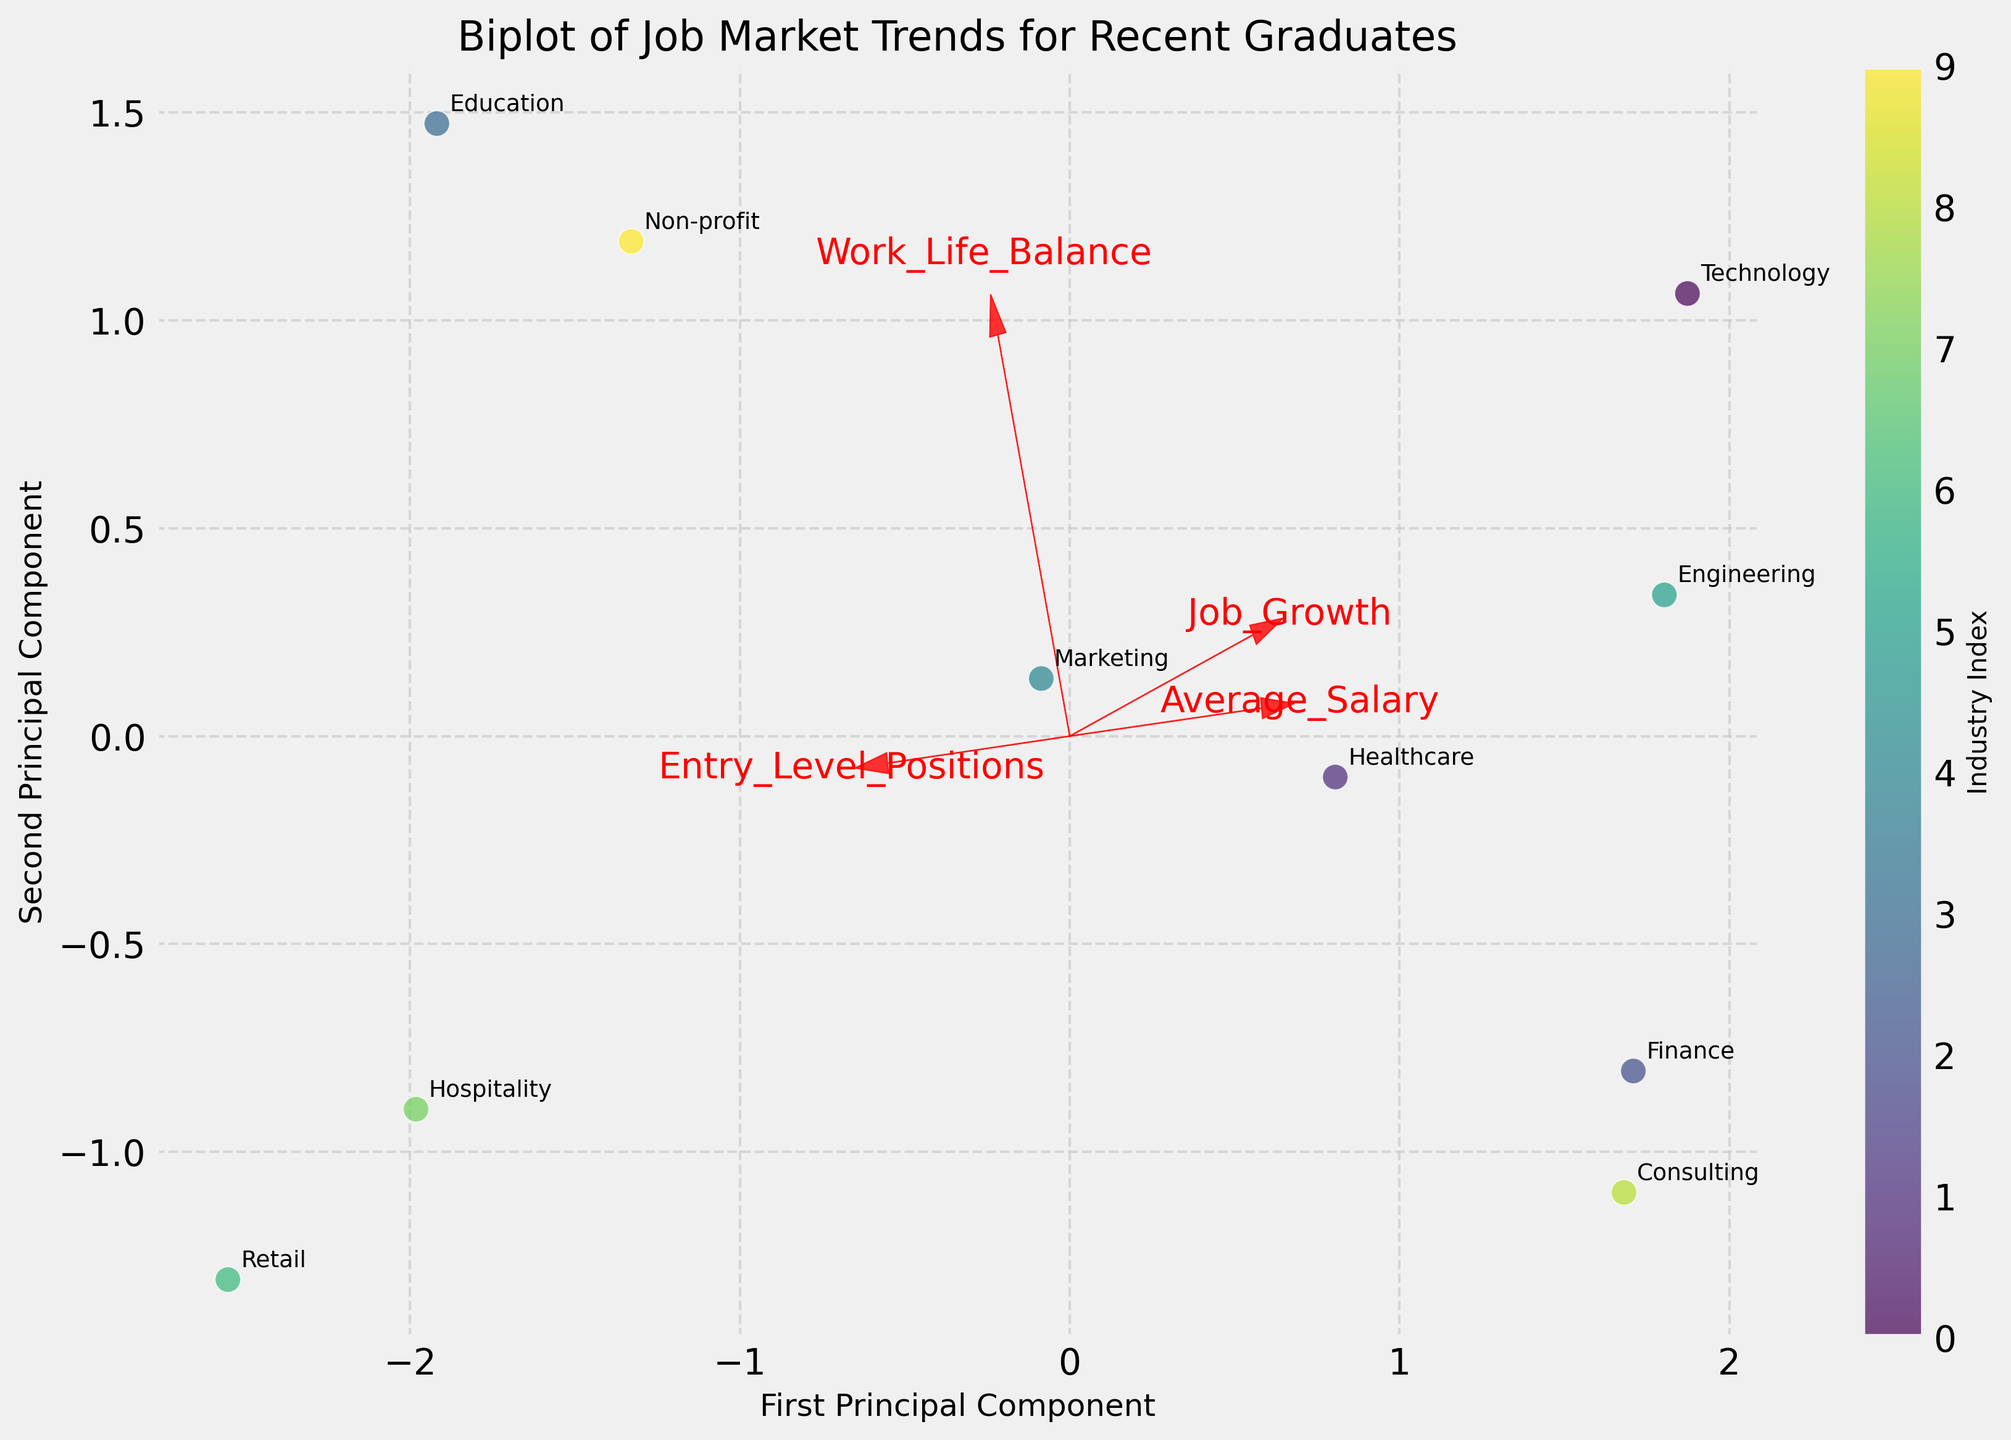What is the title of the plot? The title is usually placed at the top of the plot and provides a summary of what the plot represents. In this case, it should indicate the overall content of the plot.
Answer: Biplot of Job Market Trends for Recent Graduates How many industries are displayed in the plot? Each industry is represented by a labeled point on the plot. Count the number of unique labels to determine the number of industries.
Answer: 10 Which industry is situated furthest to the right on the first principal component? The first principal component is represented by the x-axis. Find the industry label located at the highest positive value on the x-axis.
Answer: Technology Which feature vector points most upwards? Feature vectors (arrows representing features) indicate the direction and strength of each feature. Look at which arrow has the highest value on the y-axis.
Answer: Entry_Level_Positions Which two features are the most similar in direction? Check the orientation of the arrows (feature vectors). The most similar directions will have arrows pointing in nearly the same direction.
Answer: Average_Salary and Job_Growth Which industry appears closest to the origin on the plot? The origin is the (0,0) point on the plot. Identify which industry's label is nearest to this point.
Answer: Consulting Which industry shows a higher preference for work-life balance compared to its job growth and average salary? Identify the location of Work_Life_Balance's vector relative to the other features and then find the industry that is closely aligned along this vector.
Answer: Education Which two industries appear closest to each other on the plot? Measure the distance between the points representing industries. The two with the smallest distance are the closest to each other.
Answer: Healthcare and Non-profit Which feature seems to have the least influence on the first principal component? The length and direction of each arrow indicate their influence on the principal components. Identify the arrow that contributes least to the direction of the first principal component.
Answer: Work_Life_Balance How does the length of the arrows relate to the importance of the features? Generally, in a biplot, the longer the arrow, the more significant the feature's influence on the first and second principal components. Here, you would compare the lengths of the vectors.
Answer: Longer arrows indicate greater importance 